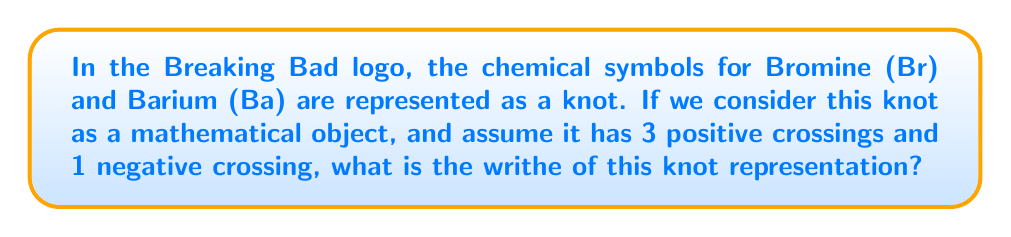Can you answer this question? To calculate the writhe of a knot representation, we need to follow these steps:

1. Identify the number of positive and negative crossings:
   - Positive crossings: 3
   - Negative crossings: 1

2. Recall the formula for writhe:
   $$ \text{Writhe} = \text{number of positive crossings} - \text{number of negative crossings} $$

3. Substitute the values into the formula:
   $$ \text{Writhe} = 3 - 1 $$

4. Perform the calculation:
   $$ \text{Writhe} = 2 $$

The writhe of the knot representation of the Breaking Bad logo, given the assumed crossings, is 2.

Fun fact: The Breaking Bad logo's design was inspired by the periodic table, much like the show's emphasis on chemistry. The knot-like representation adds a unique twist, symbolizing the complex and intertwined nature of the show's plot.
Answer: 2 